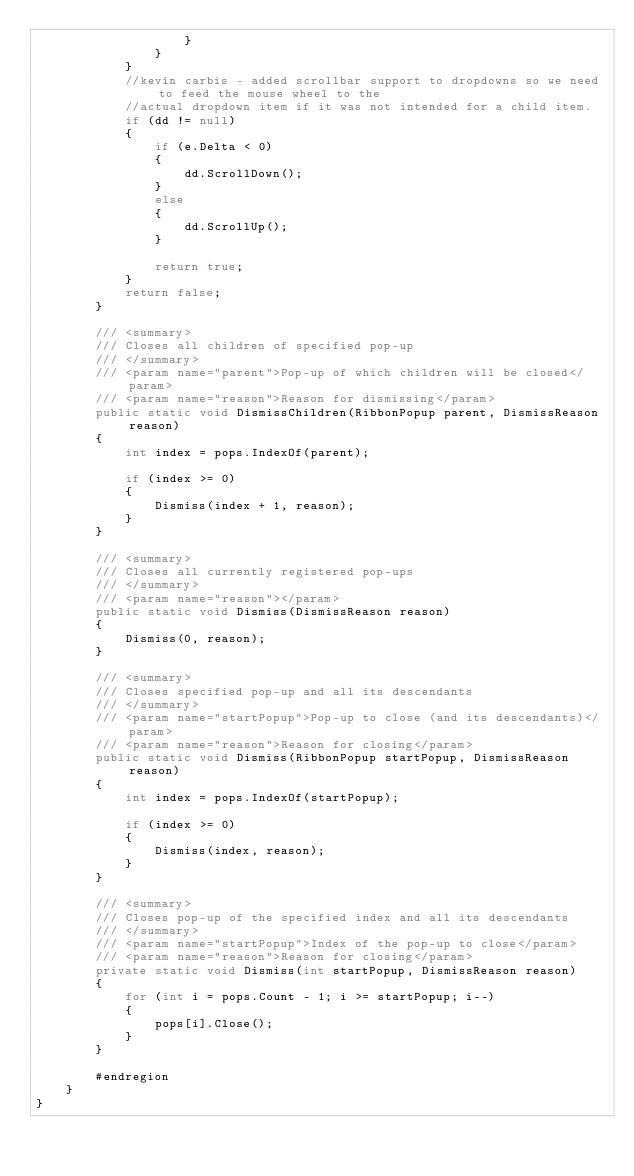<code> <loc_0><loc_0><loc_500><loc_500><_C#_>                    }
                }
            }
            //kevin carbis - added scrollbar support to dropdowns so we need to feed the mouse wheel to the 
            //actual dropdown item if it was not intended for a child item.
            if (dd != null)
            {
                if (e.Delta < 0)
                {
                    dd.ScrollDown();
                }
                else
                {
                    dd.ScrollUp();
                }

                return true;
            }
            return false;
        }

        /// <summary>
        /// Closes all children of specified pop-up
        /// </summary>
        /// <param name="parent">Pop-up of which children will be closed</param>
        /// <param name="reason">Reason for dismissing</param>
        public static void DismissChildren(RibbonPopup parent, DismissReason reason)
        {
            int index = pops.IndexOf(parent);

            if (index >= 0)
            {
                Dismiss(index + 1, reason);
            }
        }

        /// <summary>
        /// Closes all currently registered pop-ups
        /// </summary>
        /// <param name="reason"></param>
        public static void Dismiss(DismissReason reason)
        {
            Dismiss(0, reason);
        }

        /// <summary>
        /// Closes specified pop-up and all its descendants
        /// </summary>
        /// <param name="startPopup">Pop-up to close (and its descendants)</param>
        /// <param name="reason">Reason for closing</param>
        public static void Dismiss(RibbonPopup startPopup, DismissReason reason)
        {
            int index = pops.IndexOf(startPopup);

            if (index >= 0)
            {
                Dismiss(index, reason);
            }
        }

        /// <summary>
        /// Closes pop-up of the specified index and all its descendants
        /// </summary>
        /// <param name="startPopup">Index of the pop-up to close</param>
        /// <param name="reason">Reason for closing</param>
        private static void Dismiss(int startPopup, DismissReason reason)
        {
            for (int i = pops.Count - 1; i >= startPopup; i--)
            {
                pops[i].Close();
            }
        }

        #endregion
    }
}
</code> 